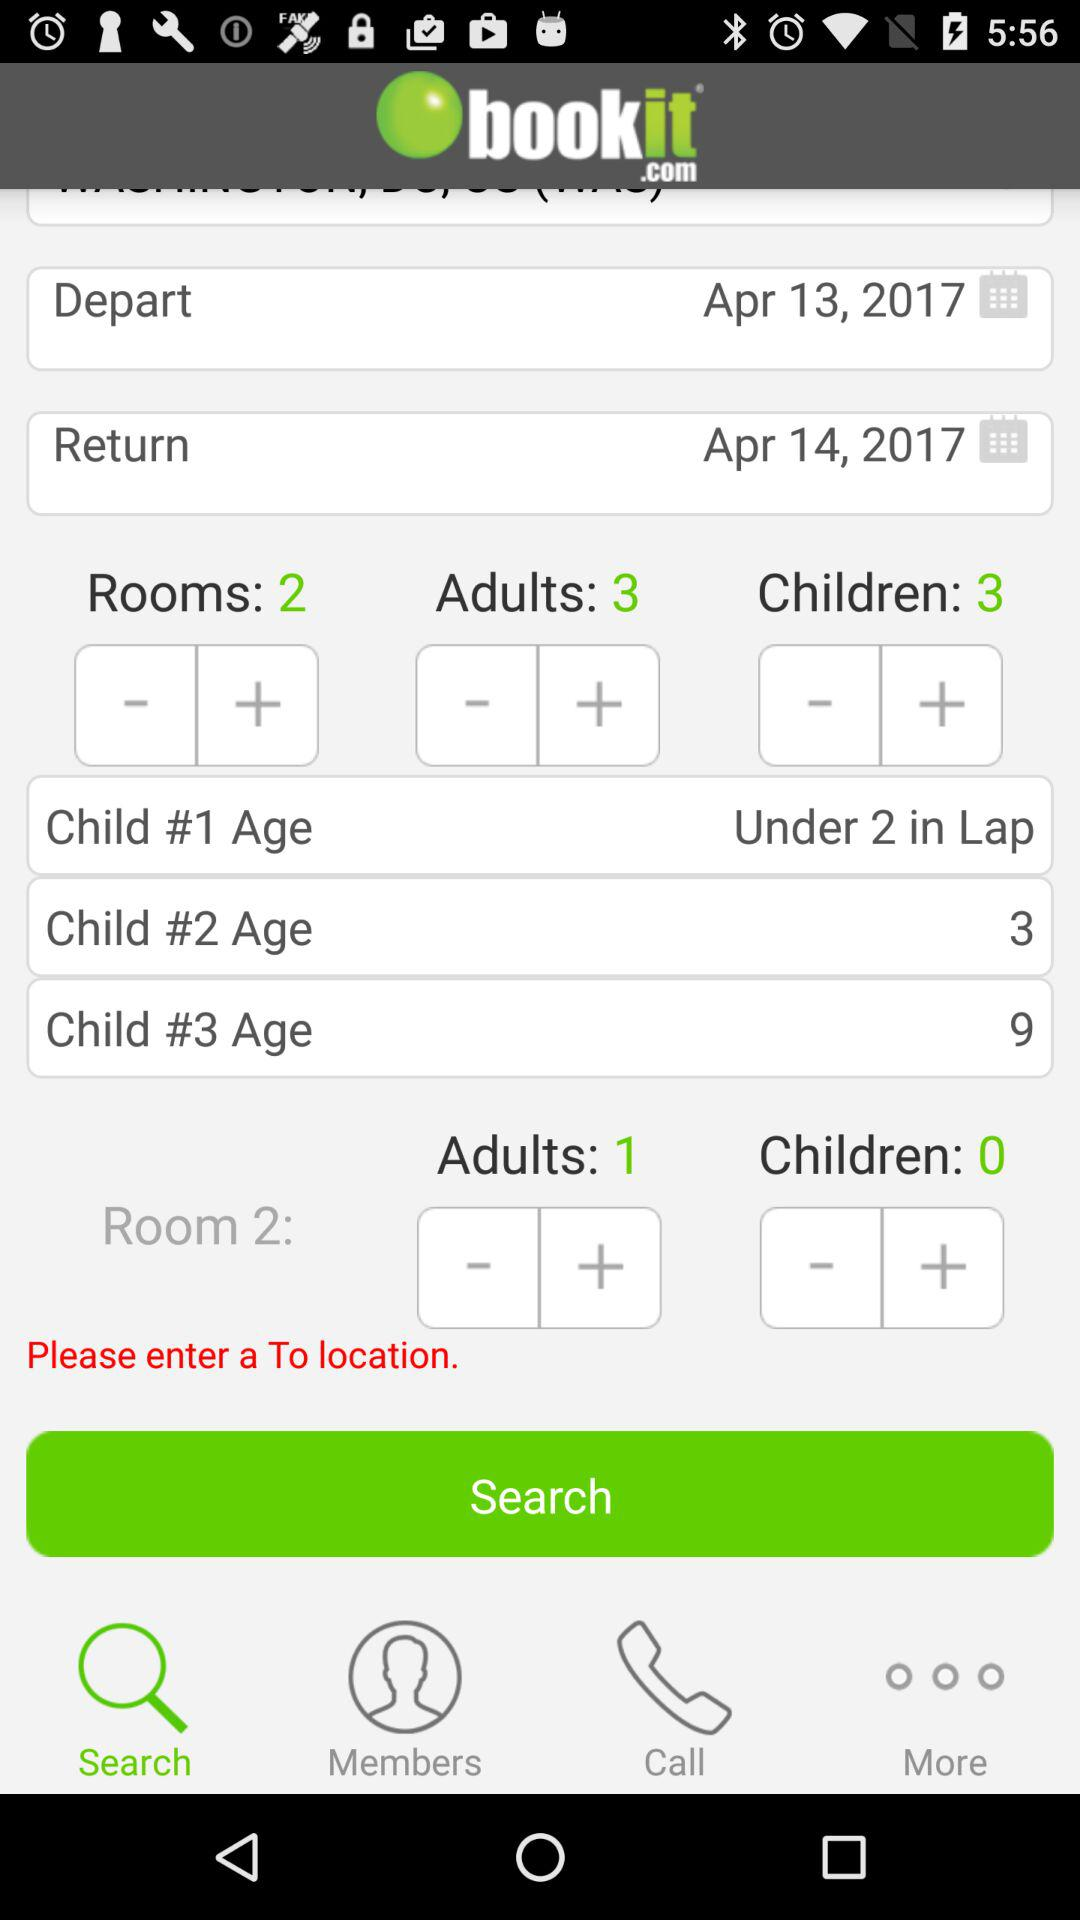What is the number of adults? The number of adults is 3. 